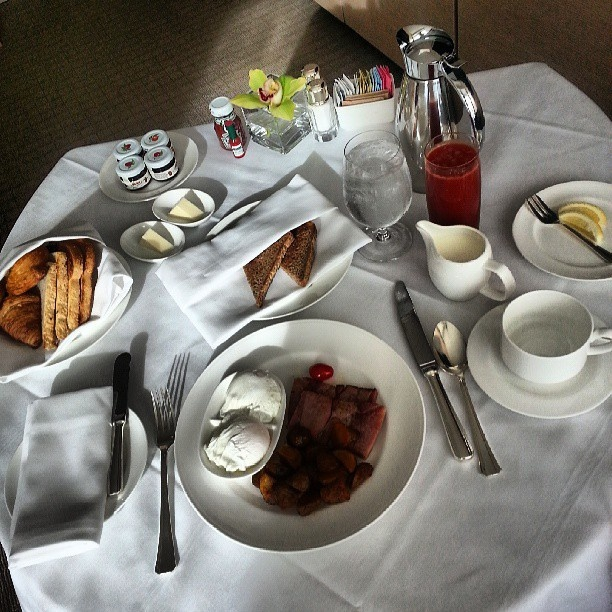Describe the objects in this image and their specific colors. I can see dining table in darkgray, gray, lightgray, and black tones, cup in gray, lightgray, and darkgray tones, bowl in gray, ivory, and darkgray tones, wine glass in gray, darkgray, and black tones, and cup in gray, lightgray, and darkgray tones in this image. 